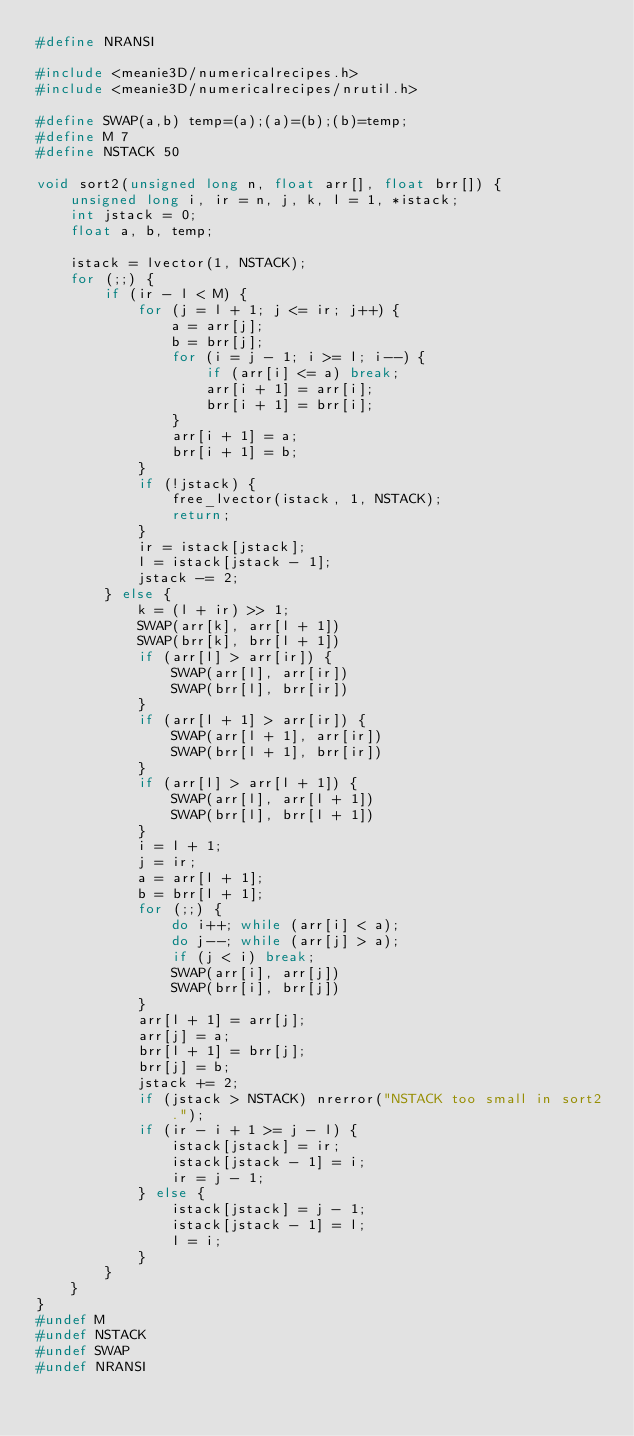Convert code to text. <code><loc_0><loc_0><loc_500><loc_500><_C_>#define NRANSI

#include <meanie3D/numericalrecipes.h>
#include <meanie3D/numericalrecipes/nrutil.h>

#define SWAP(a,b) temp=(a);(a)=(b);(b)=temp;
#define M 7
#define NSTACK 50

void sort2(unsigned long n, float arr[], float brr[]) {
    unsigned long i, ir = n, j, k, l = 1, *istack;
    int jstack = 0;
    float a, b, temp;

    istack = lvector(1, NSTACK);
    for (;;) {
        if (ir - l < M) {
            for (j = l + 1; j <= ir; j++) {
                a = arr[j];
                b = brr[j];
                for (i = j - 1; i >= l; i--) {
                    if (arr[i] <= a) break;
                    arr[i + 1] = arr[i];
                    brr[i + 1] = brr[i];
                }
                arr[i + 1] = a;
                brr[i + 1] = b;
            }
            if (!jstack) {
                free_lvector(istack, 1, NSTACK);
                return;
            }
            ir = istack[jstack];
            l = istack[jstack - 1];
            jstack -= 2;
        } else {
            k = (l + ir) >> 1;
            SWAP(arr[k], arr[l + 1])
            SWAP(brr[k], brr[l + 1])
            if (arr[l] > arr[ir]) {
                SWAP(arr[l], arr[ir])
                SWAP(brr[l], brr[ir])
            }
            if (arr[l + 1] > arr[ir]) {
                SWAP(arr[l + 1], arr[ir])
                SWAP(brr[l + 1], brr[ir])
            }
            if (arr[l] > arr[l + 1]) {
                SWAP(arr[l], arr[l + 1])
                SWAP(brr[l], brr[l + 1])
            }
            i = l + 1;
            j = ir;
            a = arr[l + 1];
            b = brr[l + 1];
            for (;;) {
                do i++; while (arr[i] < a);
                do j--; while (arr[j] > a);
                if (j < i) break;
                SWAP(arr[i], arr[j])
                SWAP(brr[i], brr[j])
            }
            arr[l + 1] = arr[j];
            arr[j] = a;
            brr[l + 1] = brr[j];
            brr[j] = b;
            jstack += 2;
            if (jstack > NSTACK) nrerror("NSTACK too small in sort2.");
            if (ir - i + 1 >= j - l) {
                istack[jstack] = ir;
                istack[jstack - 1] = i;
                ir = j - 1;
            } else {
                istack[jstack] = j - 1;
                istack[jstack - 1] = l;
                l = i;
            }
        }
    }
}
#undef M
#undef NSTACK
#undef SWAP
#undef NRANSI
</code> 